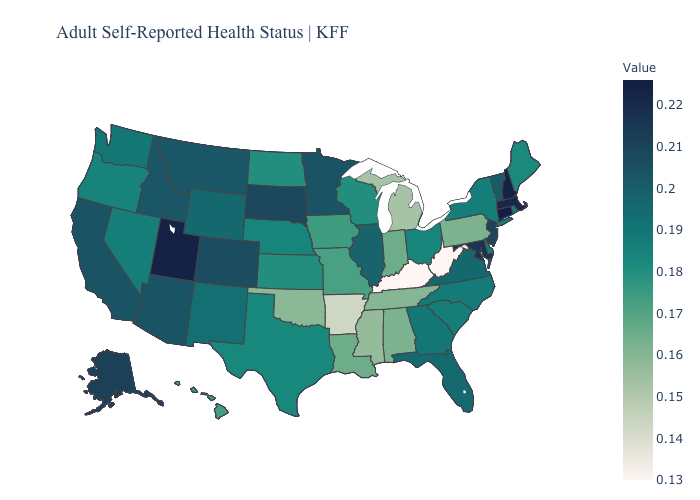Which states have the lowest value in the USA?
Answer briefly. Kentucky, West Virginia. Among the states that border Nevada , which have the highest value?
Write a very short answer. Utah. Does Utah have the highest value in the West?
Be succinct. Yes. Which states have the lowest value in the West?
Write a very short answer. Hawaii. Which states have the lowest value in the South?
Keep it brief. Kentucky, West Virginia. Which states have the lowest value in the USA?
Short answer required. Kentucky, West Virginia. 